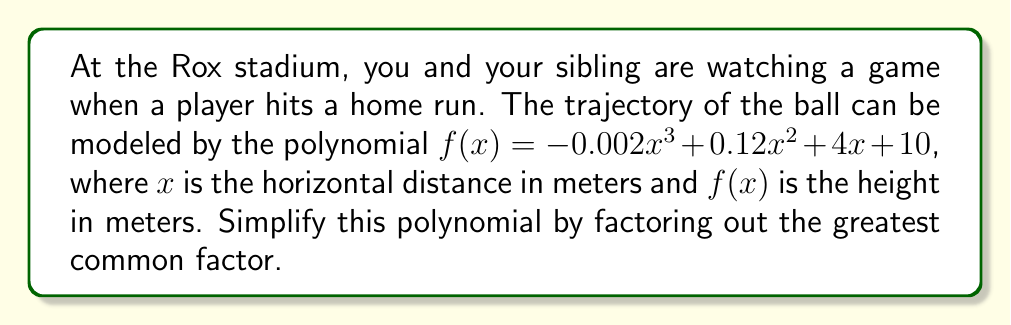Give your solution to this math problem. To simplify this polynomial by factoring out the greatest common factor (GCF), we need to follow these steps:

1) First, identify the GCF of all terms in the polynomial:
   $-0.002x^3$, $0.12x^2$, $4x$, and $10$

2) Find the GCF of the coefficients:
   $GCF(-0.002, 0.12, 4, 10) = 0.002$

3) Find the GCF of the variable terms:
   The lowest power of $x$ is $x^0 = 1$ (in the constant term)

4) Therefore, the overall GCF is $0.002$

5) Divide each term by the GCF:
   
   $-0.002x^3 \div 0.002 = -x^3$
   $0.12x^2 \div 0.002 = 60x^2$
   $4x \div 0.002 = 2000x$
   $10 \div 0.002 = 5000$

6) Write the factored polynomial:

   $f(x) = 0.002(-x^3 + 60x^2 + 2000x + 5000)$

This is the simplified form with the greatest common factor factored out.
Answer: $f(x) = 0.002(-x^3 + 60x^2 + 2000x + 5000)$ 